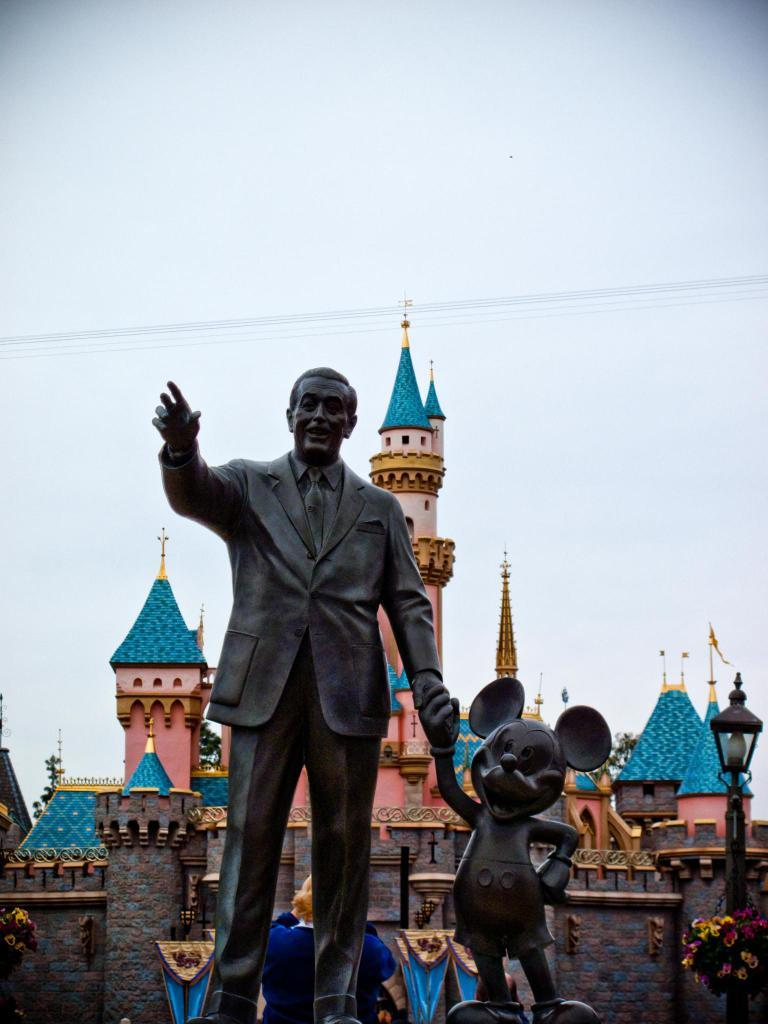What can be seen in the foreground of the image? There are two statues in the foreground of the image. What is located in the background of the image? There is a castle in the background of the image. What is on the right side of the image? There is a light pole on the right side of the image. What is visible at the top of the image? The sky is visible at the top of the image. What type of fiction is being performed by the statues in the image? There are no statues performing fiction in the image; they are stationary objects. 